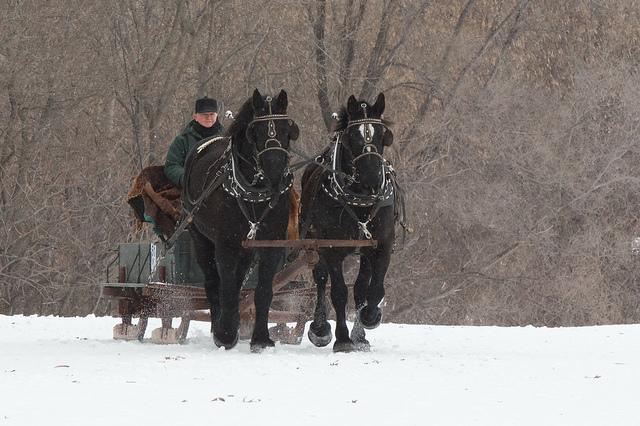What is on the ground?
Short answer required. Snow. Is it winter?
Give a very brief answer. Yes. How many horses are shown?
Write a very short answer. 2. 